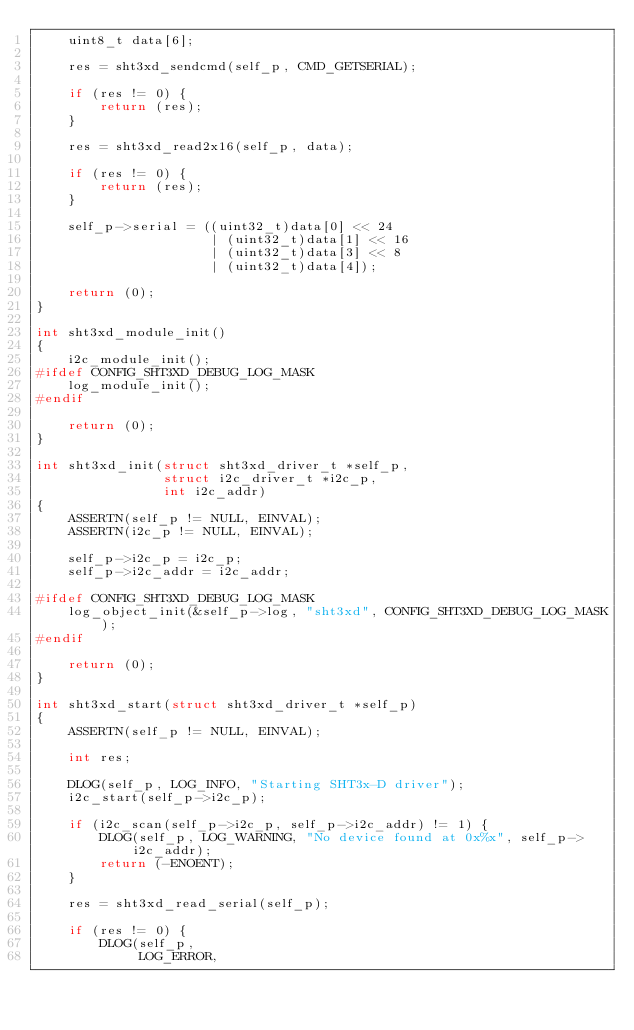<code> <loc_0><loc_0><loc_500><loc_500><_C_>    uint8_t data[6];

    res = sht3xd_sendcmd(self_p, CMD_GETSERIAL);

    if (res != 0) {
        return (res);
    }

    res = sht3xd_read2x16(self_p, data);

    if (res != 0) {
        return (res);
    }

    self_p->serial = ((uint32_t)data[0] << 24
                      | (uint32_t)data[1] << 16
                      | (uint32_t)data[3] << 8
                      | (uint32_t)data[4]);

    return (0);
}

int sht3xd_module_init()
{
    i2c_module_init();
#ifdef CONFIG_SHT3XD_DEBUG_LOG_MASK
    log_module_init();
#endif

    return (0);
}

int sht3xd_init(struct sht3xd_driver_t *self_p,
                struct i2c_driver_t *i2c_p,
                int i2c_addr)
{
    ASSERTN(self_p != NULL, EINVAL);
    ASSERTN(i2c_p != NULL, EINVAL);

    self_p->i2c_p = i2c_p;
    self_p->i2c_addr = i2c_addr;

#ifdef CONFIG_SHT3XD_DEBUG_LOG_MASK
    log_object_init(&self_p->log, "sht3xd", CONFIG_SHT3XD_DEBUG_LOG_MASK);
#endif

    return (0);
}

int sht3xd_start(struct sht3xd_driver_t *self_p)
{
    ASSERTN(self_p != NULL, EINVAL);

    int res;

    DLOG(self_p, LOG_INFO, "Starting SHT3x-D driver");
    i2c_start(self_p->i2c_p);

    if (i2c_scan(self_p->i2c_p, self_p->i2c_addr) != 1) {
        DLOG(self_p, LOG_WARNING, "No device found at 0x%x", self_p->i2c_addr);
        return (-ENOENT);
    }

    res = sht3xd_read_serial(self_p);

    if (res != 0) {
        DLOG(self_p,
             LOG_ERROR,</code> 